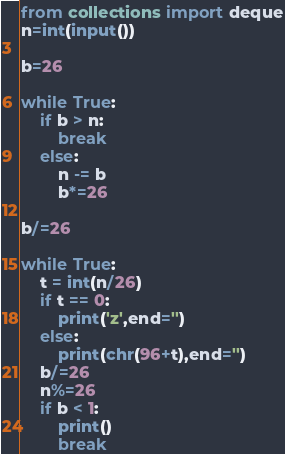<code> <loc_0><loc_0><loc_500><loc_500><_Python_>from collections import deque
n=int(input())

b=26

while True:
    if b > n:
        break
    else:
        n -= b
        b*=26

b/=26

while True:
    t = int(n/26)
    if t == 0:
        print('z',end='')
    else:
        print(chr(96+t),end='')
    b/=26
    n%=26
    if b < 1:
        print()
        break
</code> 